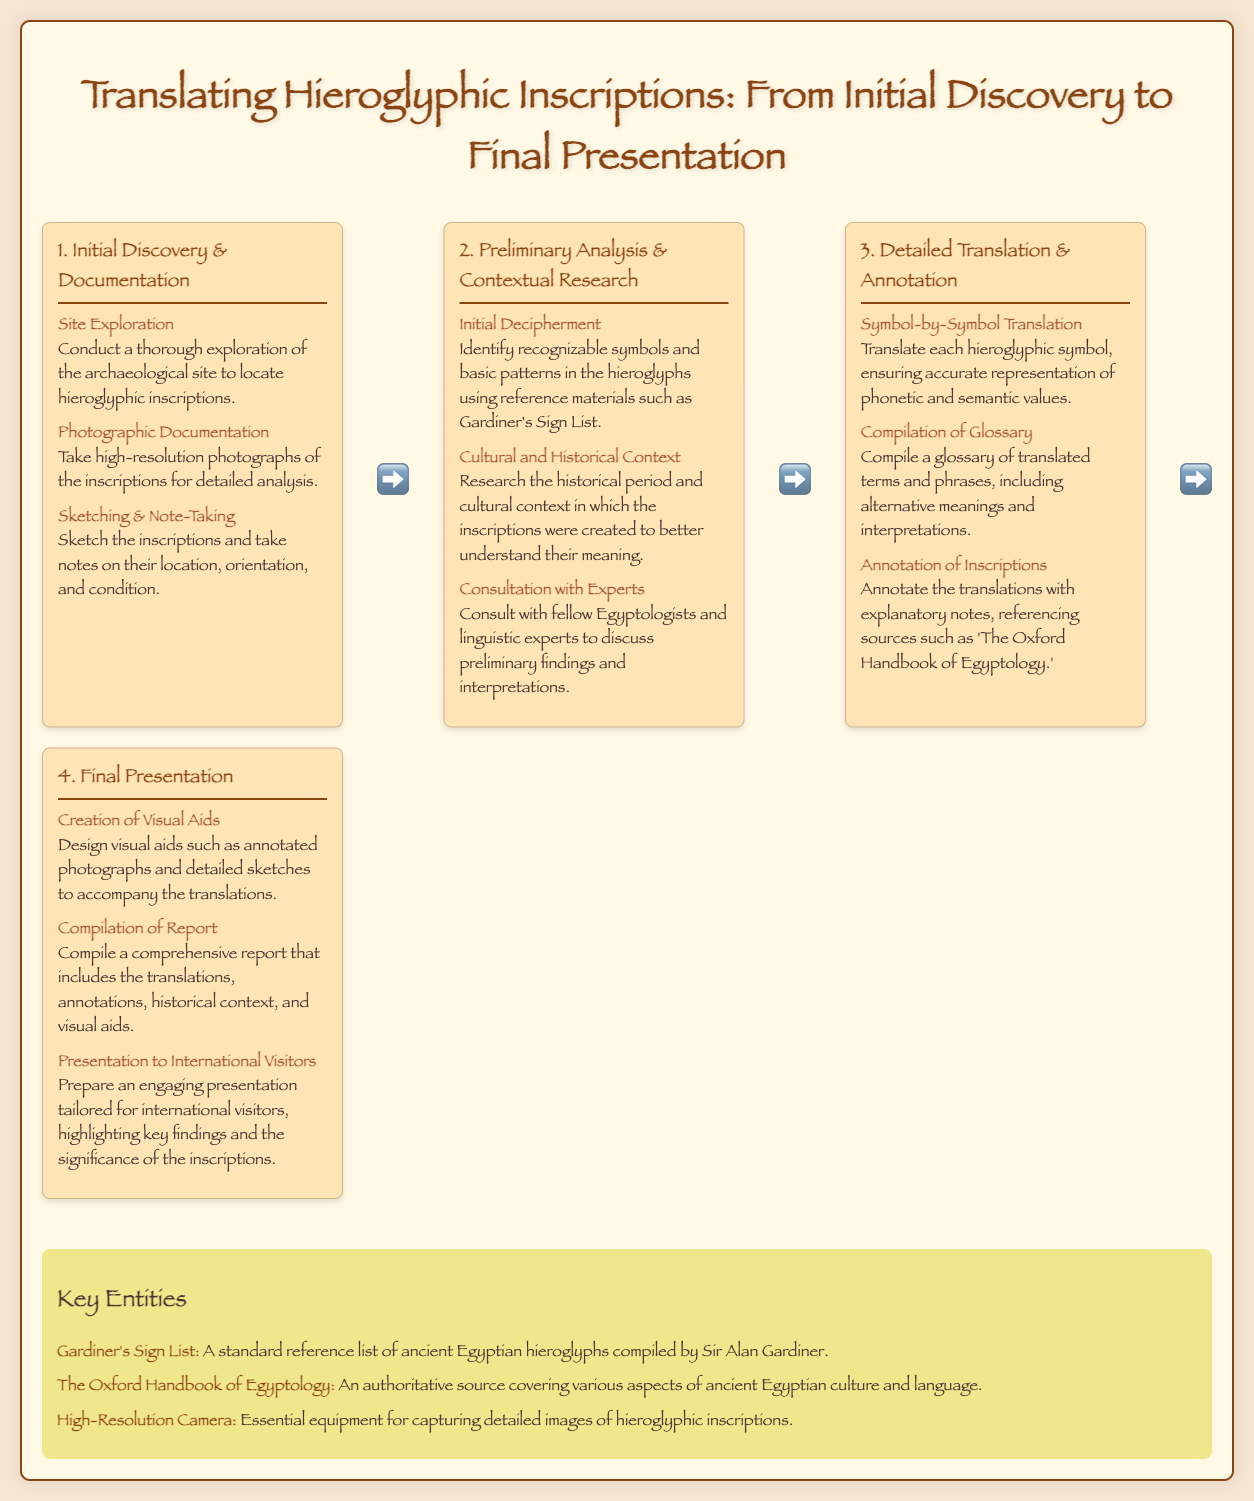What is the first step in the translation process? The first step outlined in the process infographic is "Initial Discovery & Documentation".
Answer: Initial Discovery & Documentation What is the purpose of taking high-resolution photographs? High-resolution photographs are taken for detailed analysis of the inscriptions.
Answer: Detailed analysis What reference material is used for initial decipherment? The reference material mentioned for initial decipherment is Gardiner's Sign List.
Answer: Gardiner's Sign List What is created to accompany the translations during the final presentation? Visual aids such as annotated photographs and detailed sketches are created to accompany the translations.
Answer: Visual aids How many sub-steps are there in the third step of the process? The third step, "Detailed Translation & Annotation", contains three sub-steps.
Answer: Three What is compiled in the final report? The report compiles translations, annotations, historical context, and visual aids.
Answer: Translations, annotations, historical context, and visual aids What is the purpose of consulting with experts during the preliminary analysis? Consulting with experts helps to discuss preliminary findings and interpretations.
Answer: Discuss preliminary findings and interpretations What is an essential piece of equipment for capturing detailed images of hieroglyphic inscriptions? A high-resolution camera is essential for capturing detailed images.
Answer: High-Resolution Camera 